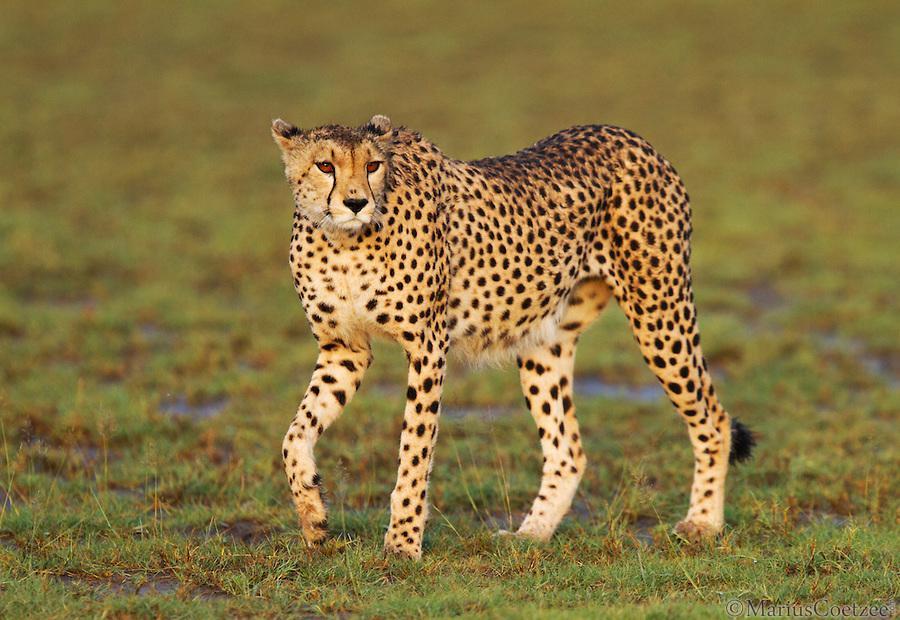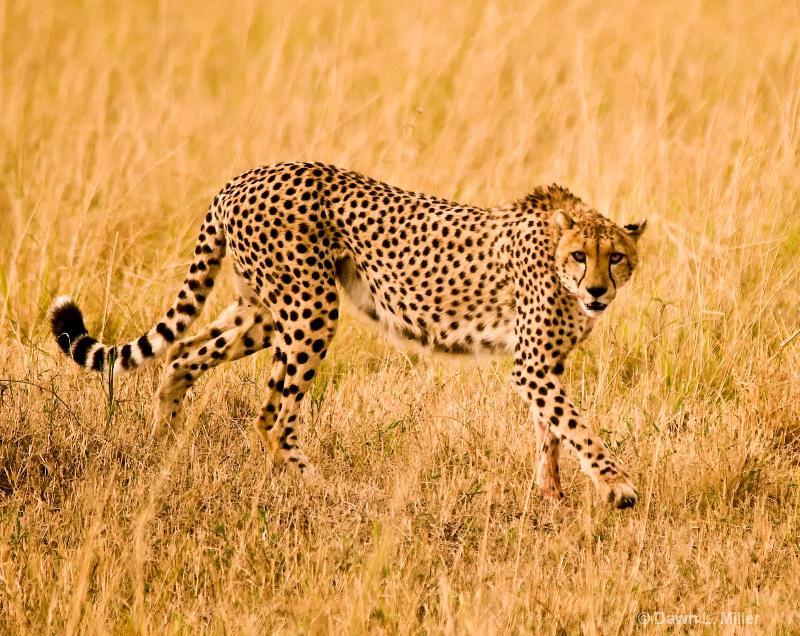The first image is the image on the left, the second image is the image on the right. Given the left and right images, does the statement "Two of the cats in the image on the right are lying on the ground." hold true? Answer yes or no. No. The first image is the image on the left, the second image is the image on the right. Analyze the images presented: Is the assertion "The right image contains no more than two cheetahs." valid? Answer yes or no. Yes. 